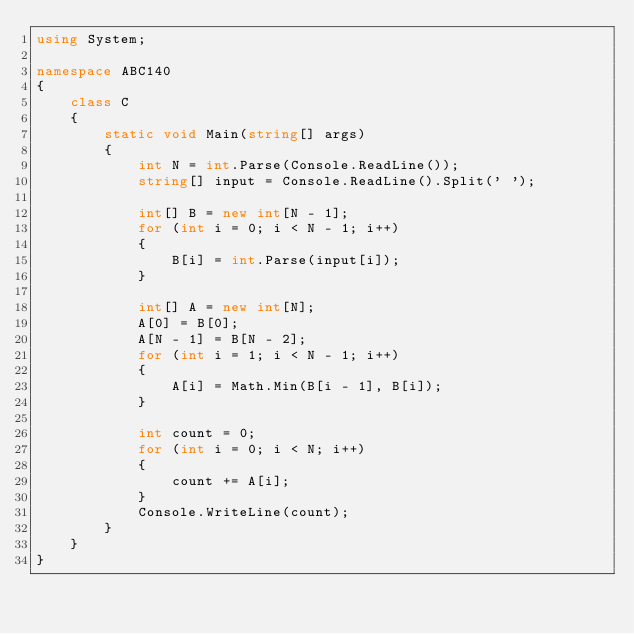Convert code to text. <code><loc_0><loc_0><loc_500><loc_500><_C#_>using System;

namespace ABC140
{
    class C
    {
        static void Main(string[] args)
        {
            int N = int.Parse(Console.ReadLine());
            string[] input = Console.ReadLine().Split(' ');

            int[] B = new int[N - 1];
            for (int i = 0; i < N - 1; i++)
            {
                B[i] = int.Parse(input[i]);
            }

            int[] A = new int[N];
            A[0] = B[0];
            A[N - 1] = B[N - 2];
            for (int i = 1; i < N - 1; i++)
            {
                A[i] = Math.Min(B[i - 1], B[i]);
            }

            int count = 0;
            for (int i = 0; i < N; i++)
            {
                count += A[i];
            }
            Console.WriteLine(count);
        }
    }
}
</code> 